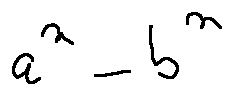Convert formula to latex. <formula><loc_0><loc_0><loc_500><loc_500>a ^ { n } - b ^ { n }</formula> 